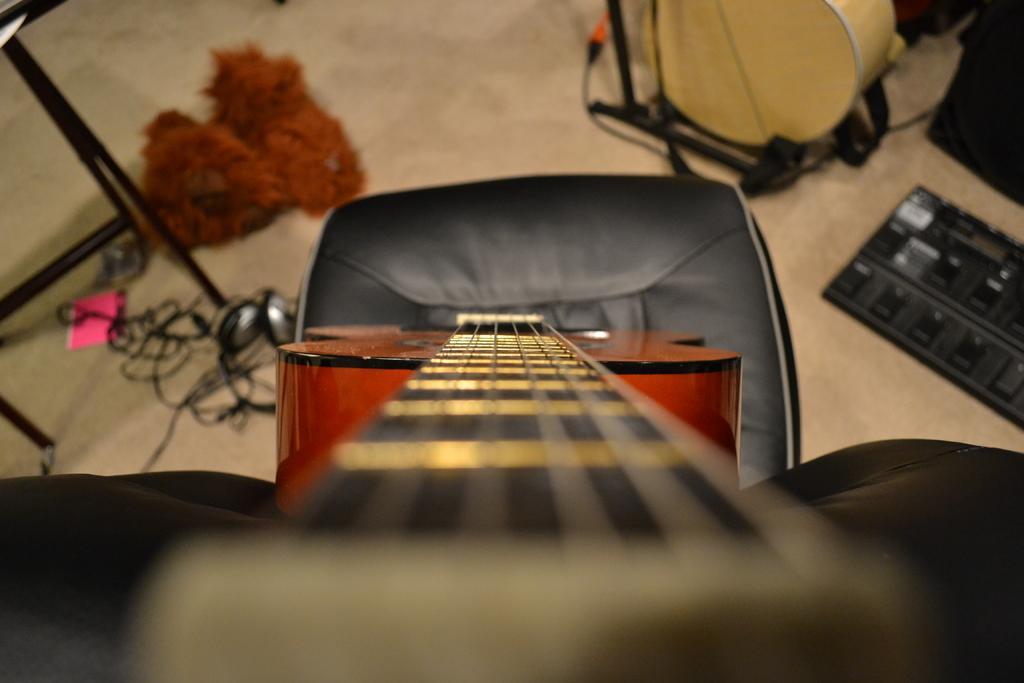Could you give a brief overview of what you see in this image? In this picture there is a guitar placed on a chair. On the floor this is a drum placed on drum stand, a toy, headset, cables and a paper. 